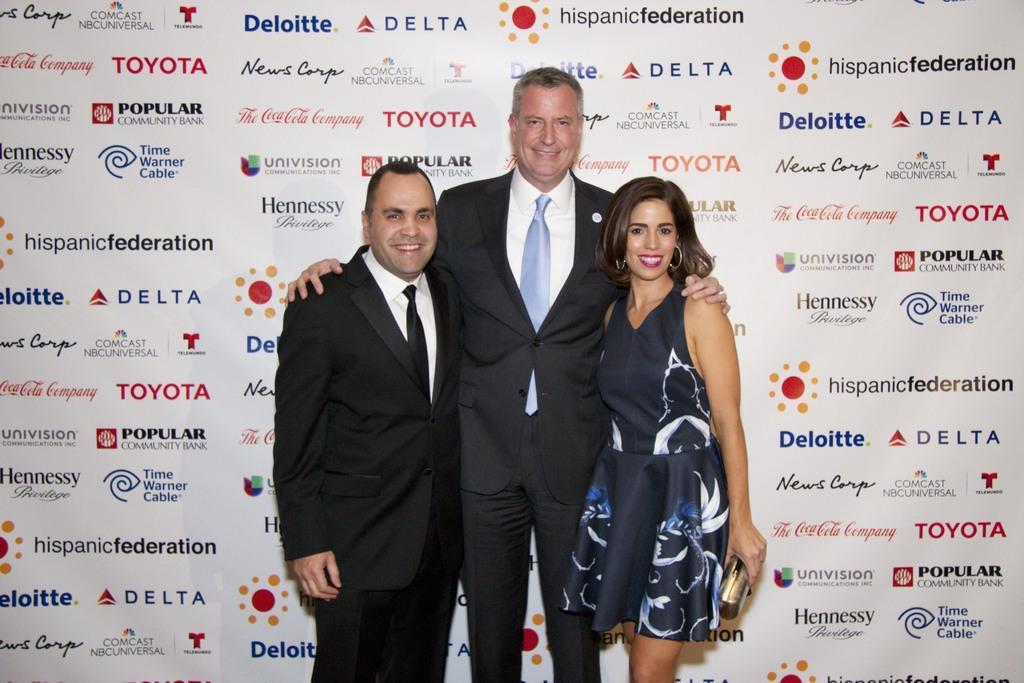Could you give a brief overview of what you see in this image? In this picture there is a man who is the wearing suit and trouser. Beside him there is another man who is wearing suit and trouser. Beside him there is a woman who is wearing earrings, dress and holding a purse. Three of them are smiling and standing near to the banner. On that banner I can see the companies name. 